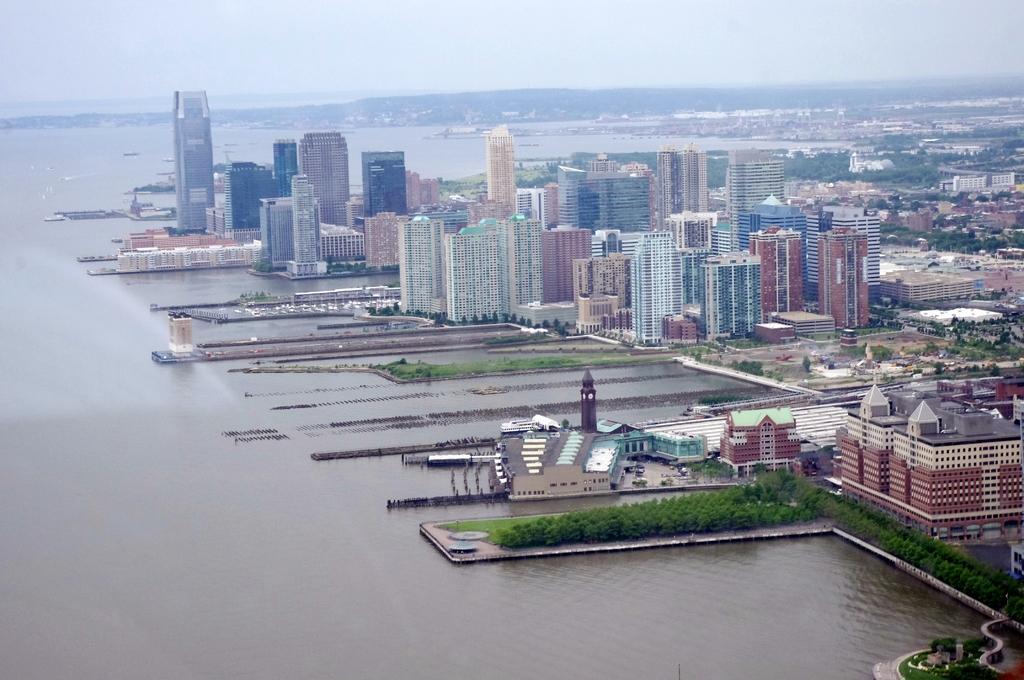How would you summarize this image in a sentence or two? In the background we can see the sky. In this picture we can see buildings, trees, water and grass. 